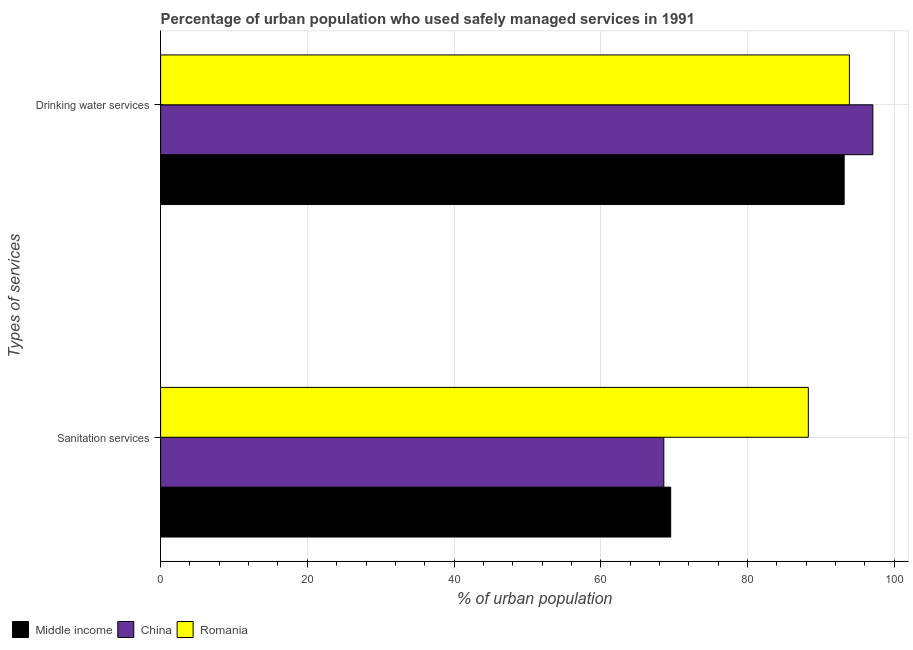How many different coloured bars are there?
Your answer should be compact. 3. Are the number of bars on each tick of the Y-axis equal?
Provide a short and direct response. Yes. How many bars are there on the 1st tick from the top?
Ensure brevity in your answer.  3. What is the label of the 2nd group of bars from the top?
Offer a terse response. Sanitation services. What is the percentage of urban population who used sanitation services in Romania?
Make the answer very short. 88.3. Across all countries, what is the maximum percentage of urban population who used sanitation services?
Make the answer very short. 88.3. Across all countries, what is the minimum percentage of urban population who used drinking water services?
Offer a very short reply. 93.19. In which country was the percentage of urban population who used sanitation services maximum?
Your answer should be very brief. Romania. In which country was the percentage of urban population who used drinking water services minimum?
Your answer should be compact. Middle income. What is the total percentage of urban population who used drinking water services in the graph?
Ensure brevity in your answer.  284.19. What is the difference between the percentage of urban population who used sanitation services in China and that in Romania?
Provide a short and direct response. -19.7. What is the difference between the percentage of urban population who used sanitation services in Middle income and the percentage of urban population who used drinking water services in China?
Provide a short and direct response. -27.56. What is the average percentage of urban population who used sanitation services per country?
Keep it short and to the point. 75.48. What is the difference between the percentage of urban population who used drinking water services and percentage of urban population who used sanitation services in Middle income?
Offer a terse response. 23.65. What is the ratio of the percentage of urban population who used drinking water services in Middle income to that in Romania?
Your answer should be very brief. 0.99. Is the percentage of urban population who used drinking water services in Middle income less than that in China?
Provide a succinct answer. Yes. In how many countries, is the percentage of urban population who used drinking water services greater than the average percentage of urban population who used drinking water services taken over all countries?
Your response must be concise. 1. What does the 1st bar from the top in Drinking water services represents?
Make the answer very short. Romania. How many bars are there?
Give a very brief answer. 6. Are all the bars in the graph horizontal?
Provide a short and direct response. Yes. Does the graph contain grids?
Keep it short and to the point. Yes. What is the title of the graph?
Offer a terse response. Percentage of urban population who used safely managed services in 1991. Does "Hong Kong" appear as one of the legend labels in the graph?
Provide a succinct answer. No. What is the label or title of the X-axis?
Your answer should be compact. % of urban population. What is the label or title of the Y-axis?
Your answer should be compact. Types of services. What is the % of urban population of Middle income in Sanitation services?
Offer a very short reply. 69.54. What is the % of urban population of China in Sanitation services?
Your answer should be compact. 68.6. What is the % of urban population of Romania in Sanitation services?
Your answer should be very brief. 88.3. What is the % of urban population of Middle income in Drinking water services?
Keep it short and to the point. 93.19. What is the % of urban population in China in Drinking water services?
Offer a very short reply. 97.1. What is the % of urban population in Romania in Drinking water services?
Ensure brevity in your answer.  93.9. Across all Types of services, what is the maximum % of urban population in Middle income?
Your answer should be compact. 93.19. Across all Types of services, what is the maximum % of urban population in China?
Ensure brevity in your answer.  97.1. Across all Types of services, what is the maximum % of urban population of Romania?
Your response must be concise. 93.9. Across all Types of services, what is the minimum % of urban population of Middle income?
Keep it short and to the point. 69.54. Across all Types of services, what is the minimum % of urban population in China?
Offer a terse response. 68.6. Across all Types of services, what is the minimum % of urban population of Romania?
Provide a succinct answer. 88.3. What is the total % of urban population in Middle income in the graph?
Provide a succinct answer. 162.72. What is the total % of urban population in China in the graph?
Provide a short and direct response. 165.7. What is the total % of urban population in Romania in the graph?
Offer a terse response. 182.2. What is the difference between the % of urban population of Middle income in Sanitation services and that in Drinking water services?
Offer a very short reply. -23.65. What is the difference between the % of urban population in China in Sanitation services and that in Drinking water services?
Keep it short and to the point. -28.5. What is the difference between the % of urban population in Middle income in Sanitation services and the % of urban population in China in Drinking water services?
Keep it short and to the point. -27.56. What is the difference between the % of urban population in Middle income in Sanitation services and the % of urban population in Romania in Drinking water services?
Ensure brevity in your answer.  -24.36. What is the difference between the % of urban population in China in Sanitation services and the % of urban population in Romania in Drinking water services?
Your answer should be compact. -25.3. What is the average % of urban population in Middle income per Types of services?
Offer a very short reply. 81.36. What is the average % of urban population in China per Types of services?
Your answer should be compact. 82.85. What is the average % of urban population in Romania per Types of services?
Your answer should be compact. 91.1. What is the difference between the % of urban population of Middle income and % of urban population of China in Sanitation services?
Offer a terse response. 0.94. What is the difference between the % of urban population in Middle income and % of urban population in Romania in Sanitation services?
Ensure brevity in your answer.  -18.76. What is the difference between the % of urban population of China and % of urban population of Romania in Sanitation services?
Your answer should be compact. -19.7. What is the difference between the % of urban population of Middle income and % of urban population of China in Drinking water services?
Offer a very short reply. -3.91. What is the difference between the % of urban population in Middle income and % of urban population in Romania in Drinking water services?
Your answer should be very brief. -0.71. What is the ratio of the % of urban population in Middle income in Sanitation services to that in Drinking water services?
Your answer should be very brief. 0.75. What is the ratio of the % of urban population of China in Sanitation services to that in Drinking water services?
Your answer should be very brief. 0.71. What is the ratio of the % of urban population of Romania in Sanitation services to that in Drinking water services?
Ensure brevity in your answer.  0.94. What is the difference between the highest and the second highest % of urban population in Middle income?
Offer a terse response. 23.65. What is the difference between the highest and the second highest % of urban population of China?
Your answer should be compact. 28.5. What is the difference between the highest and the second highest % of urban population of Romania?
Offer a very short reply. 5.6. What is the difference between the highest and the lowest % of urban population of Middle income?
Your answer should be compact. 23.65. What is the difference between the highest and the lowest % of urban population of Romania?
Your response must be concise. 5.6. 